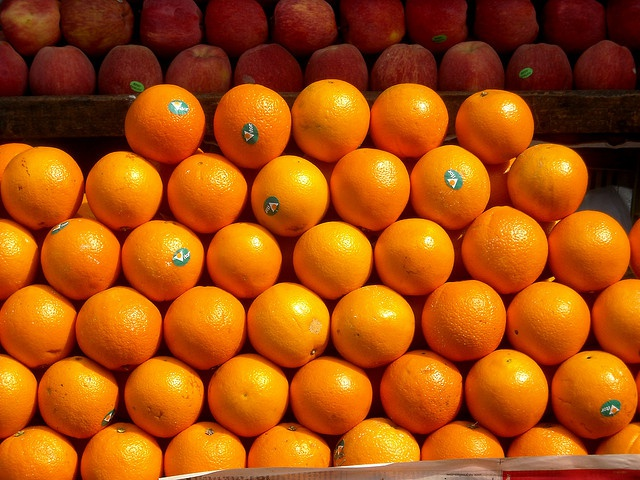Describe the objects in this image and their specific colors. I can see orange in black, red, orange, brown, and maroon tones, apple in black, maroon, and brown tones, orange in black, red, orange, and brown tones, apple in maroon and black tones, and apple in black, maroon, and gray tones in this image. 